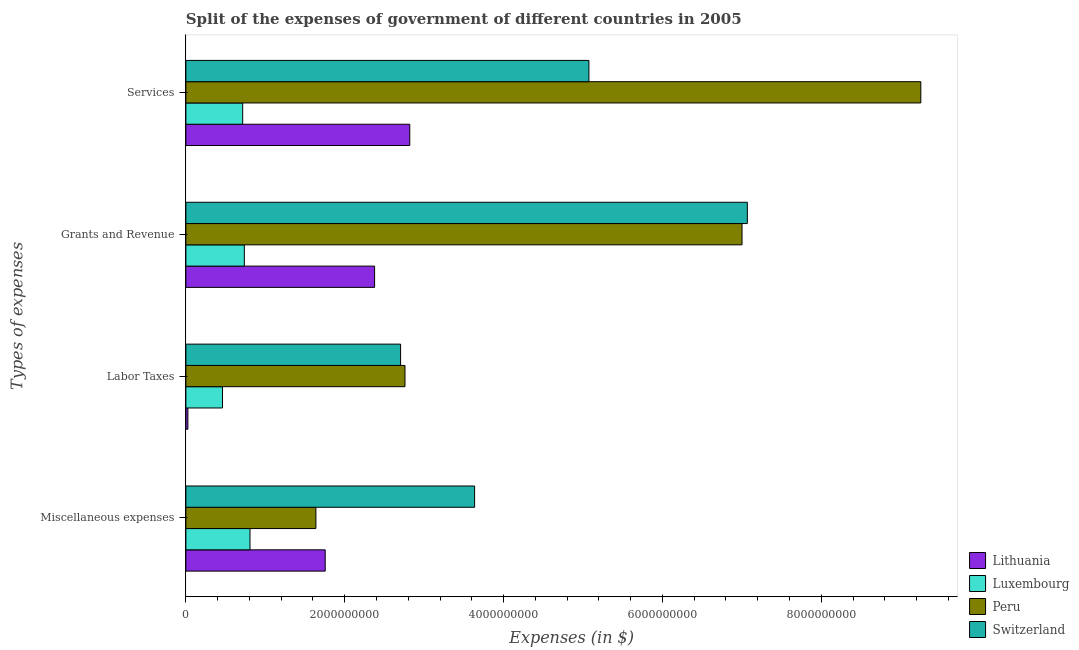How many different coloured bars are there?
Offer a terse response. 4. Are the number of bars per tick equal to the number of legend labels?
Ensure brevity in your answer.  Yes. Are the number of bars on each tick of the Y-axis equal?
Provide a short and direct response. Yes. How many bars are there on the 2nd tick from the top?
Give a very brief answer. 4. What is the label of the 4th group of bars from the top?
Provide a short and direct response. Miscellaneous expenses. What is the amount spent on labor taxes in Switzerland?
Offer a very short reply. 2.70e+09. Across all countries, what is the maximum amount spent on miscellaneous expenses?
Provide a short and direct response. 3.64e+09. Across all countries, what is the minimum amount spent on grants and revenue?
Offer a very short reply. 7.36e+08. In which country was the amount spent on grants and revenue maximum?
Provide a short and direct response. Switzerland. In which country was the amount spent on labor taxes minimum?
Ensure brevity in your answer.  Lithuania. What is the total amount spent on labor taxes in the graph?
Make the answer very short. 5.95e+09. What is the difference between the amount spent on labor taxes in Peru and that in Luxembourg?
Offer a terse response. 2.30e+09. What is the difference between the amount spent on grants and revenue in Peru and the amount spent on miscellaneous expenses in Luxembourg?
Your response must be concise. 6.20e+09. What is the average amount spent on miscellaneous expenses per country?
Provide a short and direct response. 1.96e+09. What is the difference between the amount spent on grants and revenue and amount spent on services in Peru?
Your answer should be compact. -2.25e+09. In how many countries, is the amount spent on grants and revenue greater than 2800000000 $?
Your answer should be compact. 2. What is the ratio of the amount spent on grants and revenue in Lithuania to that in Luxembourg?
Your answer should be compact. 3.23. What is the difference between the highest and the second highest amount spent on grants and revenue?
Provide a short and direct response. 6.69e+07. What is the difference between the highest and the lowest amount spent on miscellaneous expenses?
Provide a succinct answer. 2.83e+09. Is the sum of the amount spent on labor taxes in Peru and Lithuania greater than the maximum amount spent on services across all countries?
Your answer should be compact. No. What does the 4th bar from the top in Labor Taxes represents?
Make the answer very short. Lithuania. What does the 3rd bar from the bottom in Miscellaneous expenses represents?
Your response must be concise. Peru. Is it the case that in every country, the sum of the amount spent on miscellaneous expenses and amount spent on labor taxes is greater than the amount spent on grants and revenue?
Ensure brevity in your answer.  No. Are all the bars in the graph horizontal?
Provide a succinct answer. Yes. How many countries are there in the graph?
Your answer should be compact. 4. What is the difference between two consecutive major ticks on the X-axis?
Keep it short and to the point. 2.00e+09. Are the values on the major ticks of X-axis written in scientific E-notation?
Your answer should be compact. No. Does the graph contain any zero values?
Make the answer very short. No. Does the graph contain grids?
Offer a very short reply. No. Where does the legend appear in the graph?
Offer a terse response. Bottom right. How many legend labels are there?
Give a very brief answer. 4. What is the title of the graph?
Provide a short and direct response. Split of the expenses of government of different countries in 2005. What is the label or title of the X-axis?
Offer a terse response. Expenses (in $). What is the label or title of the Y-axis?
Your answer should be compact. Types of expenses. What is the Expenses (in $) of Lithuania in Miscellaneous expenses?
Provide a succinct answer. 1.75e+09. What is the Expenses (in $) in Luxembourg in Miscellaneous expenses?
Keep it short and to the point. 8.07e+08. What is the Expenses (in $) of Peru in Miscellaneous expenses?
Ensure brevity in your answer.  1.64e+09. What is the Expenses (in $) in Switzerland in Miscellaneous expenses?
Keep it short and to the point. 3.64e+09. What is the Expenses (in $) in Lithuania in Labor Taxes?
Your answer should be compact. 2.54e+07. What is the Expenses (in $) in Luxembourg in Labor Taxes?
Offer a terse response. 4.61e+08. What is the Expenses (in $) of Peru in Labor Taxes?
Your answer should be compact. 2.76e+09. What is the Expenses (in $) of Switzerland in Labor Taxes?
Keep it short and to the point. 2.70e+09. What is the Expenses (in $) of Lithuania in Grants and Revenue?
Ensure brevity in your answer.  2.38e+09. What is the Expenses (in $) in Luxembourg in Grants and Revenue?
Provide a short and direct response. 7.36e+08. What is the Expenses (in $) of Peru in Grants and Revenue?
Provide a short and direct response. 7.00e+09. What is the Expenses (in $) of Switzerland in Grants and Revenue?
Provide a succinct answer. 7.07e+09. What is the Expenses (in $) of Lithuania in Services?
Your response must be concise. 2.82e+09. What is the Expenses (in $) of Luxembourg in Services?
Give a very brief answer. 7.15e+08. What is the Expenses (in $) of Peru in Services?
Ensure brevity in your answer.  9.25e+09. What is the Expenses (in $) in Switzerland in Services?
Ensure brevity in your answer.  5.07e+09. Across all Types of expenses, what is the maximum Expenses (in $) of Lithuania?
Provide a succinct answer. 2.82e+09. Across all Types of expenses, what is the maximum Expenses (in $) in Luxembourg?
Provide a succinct answer. 8.07e+08. Across all Types of expenses, what is the maximum Expenses (in $) of Peru?
Make the answer very short. 9.25e+09. Across all Types of expenses, what is the maximum Expenses (in $) of Switzerland?
Provide a short and direct response. 7.07e+09. Across all Types of expenses, what is the minimum Expenses (in $) of Lithuania?
Your answer should be compact. 2.54e+07. Across all Types of expenses, what is the minimum Expenses (in $) of Luxembourg?
Make the answer very short. 4.61e+08. Across all Types of expenses, what is the minimum Expenses (in $) in Peru?
Provide a short and direct response. 1.64e+09. Across all Types of expenses, what is the minimum Expenses (in $) of Switzerland?
Your answer should be compact. 2.70e+09. What is the total Expenses (in $) of Lithuania in the graph?
Offer a terse response. 6.97e+09. What is the total Expenses (in $) of Luxembourg in the graph?
Provide a short and direct response. 2.72e+09. What is the total Expenses (in $) of Peru in the graph?
Provide a short and direct response. 2.07e+1. What is the total Expenses (in $) in Switzerland in the graph?
Offer a terse response. 1.85e+1. What is the difference between the Expenses (in $) of Lithuania in Miscellaneous expenses and that in Labor Taxes?
Provide a succinct answer. 1.73e+09. What is the difference between the Expenses (in $) in Luxembourg in Miscellaneous expenses and that in Labor Taxes?
Ensure brevity in your answer.  3.46e+08. What is the difference between the Expenses (in $) in Peru in Miscellaneous expenses and that in Labor Taxes?
Your answer should be very brief. -1.12e+09. What is the difference between the Expenses (in $) of Switzerland in Miscellaneous expenses and that in Labor Taxes?
Provide a succinct answer. 9.32e+08. What is the difference between the Expenses (in $) of Lithuania in Miscellaneous expenses and that in Grants and Revenue?
Your response must be concise. -6.22e+08. What is the difference between the Expenses (in $) in Luxembourg in Miscellaneous expenses and that in Grants and Revenue?
Make the answer very short. 7.10e+07. What is the difference between the Expenses (in $) of Peru in Miscellaneous expenses and that in Grants and Revenue?
Your response must be concise. -5.37e+09. What is the difference between the Expenses (in $) in Switzerland in Miscellaneous expenses and that in Grants and Revenue?
Ensure brevity in your answer.  -3.43e+09. What is the difference between the Expenses (in $) of Lithuania in Miscellaneous expenses and that in Services?
Provide a succinct answer. -1.06e+09. What is the difference between the Expenses (in $) in Luxembourg in Miscellaneous expenses and that in Services?
Provide a short and direct response. 9.18e+07. What is the difference between the Expenses (in $) in Peru in Miscellaneous expenses and that in Services?
Your answer should be very brief. -7.62e+09. What is the difference between the Expenses (in $) of Switzerland in Miscellaneous expenses and that in Services?
Ensure brevity in your answer.  -1.44e+09. What is the difference between the Expenses (in $) in Lithuania in Labor Taxes and that in Grants and Revenue?
Ensure brevity in your answer.  -2.35e+09. What is the difference between the Expenses (in $) of Luxembourg in Labor Taxes and that in Grants and Revenue?
Your answer should be very brief. -2.75e+08. What is the difference between the Expenses (in $) of Peru in Labor Taxes and that in Grants and Revenue?
Give a very brief answer. -4.24e+09. What is the difference between the Expenses (in $) of Switzerland in Labor Taxes and that in Grants and Revenue?
Your response must be concise. -4.37e+09. What is the difference between the Expenses (in $) in Lithuania in Labor Taxes and that in Services?
Give a very brief answer. -2.79e+09. What is the difference between the Expenses (in $) in Luxembourg in Labor Taxes and that in Services?
Your answer should be very brief. -2.54e+08. What is the difference between the Expenses (in $) of Peru in Labor Taxes and that in Services?
Ensure brevity in your answer.  -6.49e+09. What is the difference between the Expenses (in $) in Switzerland in Labor Taxes and that in Services?
Offer a very short reply. -2.37e+09. What is the difference between the Expenses (in $) in Lithuania in Grants and Revenue and that in Services?
Provide a succinct answer. -4.43e+08. What is the difference between the Expenses (in $) in Luxembourg in Grants and Revenue and that in Services?
Keep it short and to the point. 2.07e+07. What is the difference between the Expenses (in $) in Peru in Grants and Revenue and that in Services?
Offer a very short reply. -2.25e+09. What is the difference between the Expenses (in $) in Switzerland in Grants and Revenue and that in Services?
Your response must be concise. 1.99e+09. What is the difference between the Expenses (in $) in Lithuania in Miscellaneous expenses and the Expenses (in $) in Luxembourg in Labor Taxes?
Provide a short and direct response. 1.29e+09. What is the difference between the Expenses (in $) in Lithuania in Miscellaneous expenses and the Expenses (in $) in Peru in Labor Taxes?
Keep it short and to the point. -1.00e+09. What is the difference between the Expenses (in $) of Lithuania in Miscellaneous expenses and the Expenses (in $) of Switzerland in Labor Taxes?
Make the answer very short. -9.49e+08. What is the difference between the Expenses (in $) in Luxembourg in Miscellaneous expenses and the Expenses (in $) in Peru in Labor Taxes?
Make the answer very short. -1.95e+09. What is the difference between the Expenses (in $) of Luxembourg in Miscellaneous expenses and the Expenses (in $) of Switzerland in Labor Taxes?
Keep it short and to the point. -1.90e+09. What is the difference between the Expenses (in $) of Peru in Miscellaneous expenses and the Expenses (in $) of Switzerland in Labor Taxes?
Make the answer very short. -1.07e+09. What is the difference between the Expenses (in $) in Lithuania in Miscellaneous expenses and the Expenses (in $) in Luxembourg in Grants and Revenue?
Offer a very short reply. 1.02e+09. What is the difference between the Expenses (in $) of Lithuania in Miscellaneous expenses and the Expenses (in $) of Peru in Grants and Revenue?
Offer a terse response. -5.25e+09. What is the difference between the Expenses (in $) of Lithuania in Miscellaneous expenses and the Expenses (in $) of Switzerland in Grants and Revenue?
Offer a very short reply. -5.32e+09. What is the difference between the Expenses (in $) in Luxembourg in Miscellaneous expenses and the Expenses (in $) in Peru in Grants and Revenue?
Make the answer very short. -6.20e+09. What is the difference between the Expenses (in $) of Luxembourg in Miscellaneous expenses and the Expenses (in $) of Switzerland in Grants and Revenue?
Offer a very short reply. -6.26e+09. What is the difference between the Expenses (in $) of Peru in Miscellaneous expenses and the Expenses (in $) of Switzerland in Grants and Revenue?
Offer a terse response. -5.43e+09. What is the difference between the Expenses (in $) of Lithuania in Miscellaneous expenses and the Expenses (in $) of Luxembourg in Services?
Make the answer very short. 1.04e+09. What is the difference between the Expenses (in $) in Lithuania in Miscellaneous expenses and the Expenses (in $) in Peru in Services?
Provide a short and direct response. -7.50e+09. What is the difference between the Expenses (in $) in Lithuania in Miscellaneous expenses and the Expenses (in $) in Switzerland in Services?
Your answer should be compact. -3.32e+09. What is the difference between the Expenses (in $) of Luxembourg in Miscellaneous expenses and the Expenses (in $) of Peru in Services?
Keep it short and to the point. -8.45e+09. What is the difference between the Expenses (in $) of Luxembourg in Miscellaneous expenses and the Expenses (in $) of Switzerland in Services?
Offer a terse response. -4.27e+09. What is the difference between the Expenses (in $) in Peru in Miscellaneous expenses and the Expenses (in $) in Switzerland in Services?
Your response must be concise. -3.44e+09. What is the difference between the Expenses (in $) in Lithuania in Labor Taxes and the Expenses (in $) in Luxembourg in Grants and Revenue?
Your answer should be very brief. -7.11e+08. What is the difference between the Expenses (in $) of Lithuania in Labor Taxes and the Expenses (in $) of Peru in Grants and Revenue?
Your answer should be very brief. -6.98e+09. What is the difference between the Expenses (in $) in Lithuania in Labor Taxes and the Expenses (in $) in Switzerland in Grants and Revenue?
Make the answer very short. -7.04e+09. What is the difference between the Expenses (in $) of Luxembourg in Labor Taxes and the Expenses (in $) of Peru in Grants and Revenue?
Your answer should be very brief. -6.54e+09. What is the difference between the Expenses (in $) in Luxembourg in Labor Taxes and the Expenses (in $) in Switzerland in Grants and Revenue?
Offer a very short reply. -6.61e+09. What is the difference between the Expenses (in $) in Peru in Labor Taxes and the Expenses (in $) in Switzerland in Grants and Revenue?
Ensure brevity in your answer.  -4.31e+09. What is the difference between the Expenses (in $) of Lithuania in Labor Taxes and the Expenses (in $) of Luxembourg in Services?
Give a very brief answer. -6.90e+08. What is the difference between the Expenses (in $) in Lithuania in Labor Taxes and the Expenses (in $) in Peru in Services?
Your response must be concise. -9.23e+09. What is the difference between the Expenses (in $) of Lithuania in Labor Taxes and the Expenses (in $) of Switzerland in Services?
Your response must be concise. -5.05e+09. What is the difference between the Expenses (in $) in Luxembourg in Labor Taxes and the Expenses (in $) in Peru in Services?
Your response must be concise. -8.79e+09. What is the difference between the Expenses (in $) of Luxembourg in Labor Taxes and the Expenses (in $) of Switzerland in Services?
Keep it short and to the point. -4.61e+09. What is the difference between the Expenses (in $) in Peru in Labor Taxes and the Expenses (in $) in Switzerland in Services?
Give a very brief answer. -2.32e+09. What is the difference between the Expenses (in $) of Lithuania in Grants and Revenue and the Expenses (in $) of Luxembourg in Services?
Provide a short and direct response. 1.66e+09. What is the difference between the Expenses (in $) of Lithuania in Grants and Revenue and the Expenses (in $) of Peru in Services?
Your answer should be very brief. -6.88e+09. What is the difference between the Expenses (in $) in Lithuania in Grants and Revenue and the Expenses (in $) in Switzerland in Services?
Ensure brevity in your answer.  -2.70e+09. What is the difference between the Expenses (in $) in Luxembourg in Grants and Revenue and the Expenses (in $) in Peru in Services?
Your answer should be very brief. -8.52e+09. What is the difference between the Expenses (in $) in Luxembourg in Grants and Revenue and the Expenses (in $) in Switzerland in Services?
Ensure brevity in your answer.  -4.34e+09. What is the difference between the Expenses (in $) of Peru in Grants and Revenue and the Expenses (in $) of Switzerland in Services?
Provide a short and direct response. 1.93e+09. What is the average Expenses (in $) in Lithuania per Types of expenses?
Your answer should be very brief. 1.74e+09. What is the average Expenses (in $) in Luxembourg per Types of expenses?
Give a very brief answer. 6.80e+08. What is the average Expenses (in $) of Peru per Types of expenses?
Provide a short and direct response. 5.16e+09. What is the average Expenses (in $) in Switzerland per Types of expenses?
Offer a very short reply. 4.62e+09. What is the difference between the Expenses (in $) in Lithuania and Expenses (in $) in Luxembourg in Miscellaneous expenses?
Give a very brief answer. 9.47e+08. What is the difference between the Expenses (in $) in Lithuania and Expenses (in $) in Peru in Miscellaneous expenses?
Offer a very short reply. 1.17e+08. What is the difference between the Expenses (in $) of Lithuania and Expenses (in $) of Switzerland in Miscellaneous expenses?
Offer a terse response. -1.88e+09. What is the difference between the Expenses (in $) in Luxembourg and Expenses (in $) in Peru in Miscellaneous expenses?
Your answer should be very brief. -8.30e+08. What is the difference between the Expenses (in $) of Luxembourg and Expenses (in $) of Switzerland in Miscellaneous expenses?
Provide a short and direct response. -2.83e+09. What is the difference between the Expenses (in $) of Peru and Expenses (in $) of Switzerland in Miscellaneous expenses?
Offer a terse response. -2.00e+09. What is the difference between the Expenses (in $) of Lithuania and Expenses (in $) of Luxembourg in Labor Taxes?
Offer a terse response. -4.36e+08. What is the difference between the Expenses (in $) in Lithuania and Expenses (in $) in Peru in Labor Taxes?
Offer a terse response. -2.73e+09. What is the difference between the Expenses (in $) of Lithuania and Expenses (in $) of Switzerland in Labor Taxes?
Your response must be concise. -2.68e+09. What is the difference between the Expenses (in $) in Luxembourg and Expenses (in $) in Peru in Labor Taxes?
Your answer should be compact. -2.30e+09. What is the difference between the Expenses (in $) of Luxembourg and Expenses (in $) of Switzerland in Labor Taxes?
Offer a terse response. -2.24e+09. What is the difference between the Expenses (in $) of Peru and Expenses (in $) of Switzerland in Labor Taxes?
Provide a short and direct response. 5.55e+07. What is the difference between the Expenses (in $) of Lithuania and Expenses (in $) of Luxembourg in Grants and Revenue?
Provide a succinct answer. 1.64e+09. What is the difference between the Expenses (in $) of Lithuania and Expenses (in $) of Peru in Grants and Revenue?
Offer a terse response. -4.63e+09. What is the difference between the Expenses (in $) of Lithuania and Expenses (in $) of Switzerland in Grants and Revenue?
Your answer should be compact. -4.69e+09. What is the difference between the Expenses (in $) in Luxembourg and Expenses (in $) in Peru in Grants and Revenue?
Offer a very short reply. -6.27e+09. What is the difference between the Expenses (in $) of Luxembourg and Expenses (in $) of Switzerland in Grants and Revenue?
Give a very brief answer. -6.33e+09. What is the difference between the Expenses (in $) of Peru and Expenses (in $) of Switzerland in Grants and Revenue?
Ensure brevity in your answer.  -6.69e+07. What is the difference between the Expenses (in $) in Lithuania and Expenses (in $) in Luxembourg in Services?
Offer a very short reply. 2.10e+09. What is the difference between the Expenses (in $) of Lithuania and Expenses (in $) of Peru in Services?
Provide a succinct answer. -6.43e+09. What is the difference between the Expenses (in $) of Lithuania and Expenses (in $) of Switzerland in Services?
Ensure brevity in your answer.  -2.26e+09. What is the difference between the Expenses (in $) in Luxembourg and Expenses (in $) in Peru in Services?
Your answer should be very brief. -8.54e+09. What is the difference between the Expenses (in $) of Luxembourg and Expenses (in $) of Switzerland in Services?
Provide a succinct answer. -4.36e+09. What is the difference between the Expenses (in $) of Peru and Expenses (in $) of Switzerland in Services?
Provide a succinct answer. 4.18e+09. What is the ratio of the Expenses (in $) in Lithuania in Miscellaneous expenses to that in Labor Taxes?
Your response must be concise. 69.07. What is the ratio of the Expenses (in $) of Luxembourg in Miscellaneous expenses to that in Labor Taxes?
Provide a short and direct response. 1.75. What is the ratio of the Expenses (in $) in Peru in Miscellaneous expenses to that in Labor Taxes?
Your answer should be very brief. 0.59. What is the ratio of the Expenses (in $) in Switzerland in Miscellaneous expenses to that in Labor Taxes?
Provide a succinct answer. 1.34. What is the ratio of the Expenses (in $) in Lithuania in Miscellaneous expenses to that in Grants and Revenue?
Keep it short and to the point. 0.74. What is the ratio of the Expenses (in $) in Luxembourg in Miscellaneous expenses to that in Grants and Revenue?
Your answer should be compact. 1.1. What is the ratio of the Expenses (in $) in Peru in Miscellaneous expenses to that in Grants and Revenue?
Provide a succinct answer. 0.23. What is the ratio of the Expenses (in $) in Switzerland in Miscellaneous expenses to that in Grants and Revenue?
Keep it short and to the point. 0.51. What is the ratio of the Expenses (in $) in Lithuania in Miscellaneous expenses to that in Services?
Provide a short and direct response. 0.62. What is the ratio of the Expenses (in $) in Luxembourg in Miscellaneous expenses to that in Services?
Your response must be concise. 1.13. What is the ratio of the Expenses (in $) in Peru in Miscellaneous expenses to that in Services?
Provide a succinct answer. 0.18. What is the ratio of the Expenses (in $) in Switzerland in Miscellaneous expenses to that in Services?
Provide a short and direct response. 0.72. What is the ratio of the Expenses (in $) of Lithuania in Labor Taxes to that in Grants and Revenue?
Give a very brief answer. 0.01. What is the ratio of the Expenses (in $) of Luxembourg in Labor Taxes to that in Grants and Revenue?
Your answer should be very brief. 0.63. What is the ratio of the Expenses (in $) of Peru in Labor Taxes to that in Grants and Revenue?
Make the answer very short. 0.39. What is the ratio of the Expenses (in $) of Switzerland in Labor Taxes to that in Grants and Revenue?
Your answer should be very brief. 0.38. What is the ratio of the Expenses (in $) in Lithuania in Labor Taxes to that in Services?
Offer a very short reply. 0.01. What is the ratio of the Expenses (in $) of Luxembourg in Labor Taxes to that in Services?
Give a very brief answer. 0.64. What is the ratio of the Expenses (in $) of Peru in Labor Taxes to that in Services?
Ensure brevity in your answer.  0.3. What is the ratio of the Expenses (in $) of Switzerland in Labor Taxes to that in Services?
Offer a terse response. 0.53. What is the ratio of the Expenses (in $) of Lithuania in Grants and Revenue to that in Services?
Provide a short and direct response. 0.84. What is the ratio of the Expenses (in $) of Peru in Grants and Revenue to that in Services?
Offer a very short reply. 0.76. What is the ratio of the Expenses (in $) of Switzerland in Grants and Revenue to that in Services?
Provide a short and direct response. 1.39. What is the difference between the highest and the second highest Expenses (in $) of Lithuania?
Give a very brief answer. 4.43e+08. What is the difference between the highest and the second highest Expenses (in $) in Luxembourg?
Keep it short and to the point. 7.10e+07. What is the difference between the highest and the second highest Expenses (in $) of Peru?
Provide a short and direct response. 2.25e+09. What is the difference between the highest and the second highest Expenses (in $) of Switzerland?
Keep it short and to the point. 1.99e+09. What is the difference between the highest and the lowest Expenses (in $) in Lithuania?
Your response must be concise. 2.79e+09. What is the difference between the highest and the lowest Expenses (in $) in Luxembourg?
Keep it short and to the point. 3.46e+08. What is the difference between the highest and the lowest Expenses (in $) in Peru?
Offer a terse response. 7.62e+09. What is the difference between the highest and the lowest Expenses (in $) in Switzerland?
Offer a very short reply. 4.37e+09. 